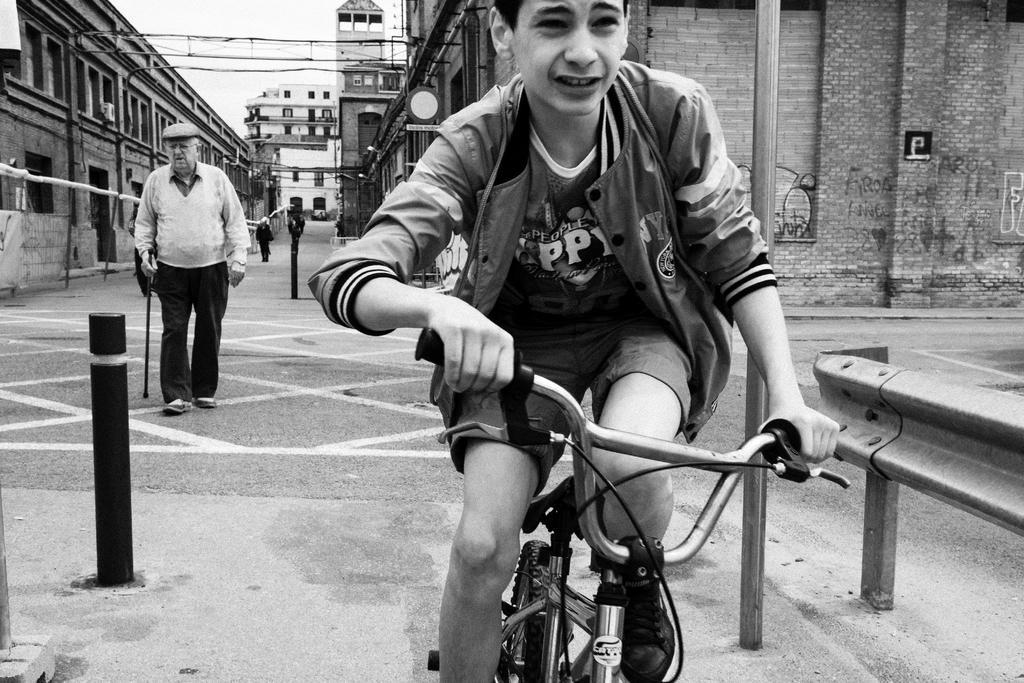How would you summarize this image in a sentence or two? In this image I see a boy who is on the cycle and there is a man who is on the path. In the background I see the buildings and a person over here. 